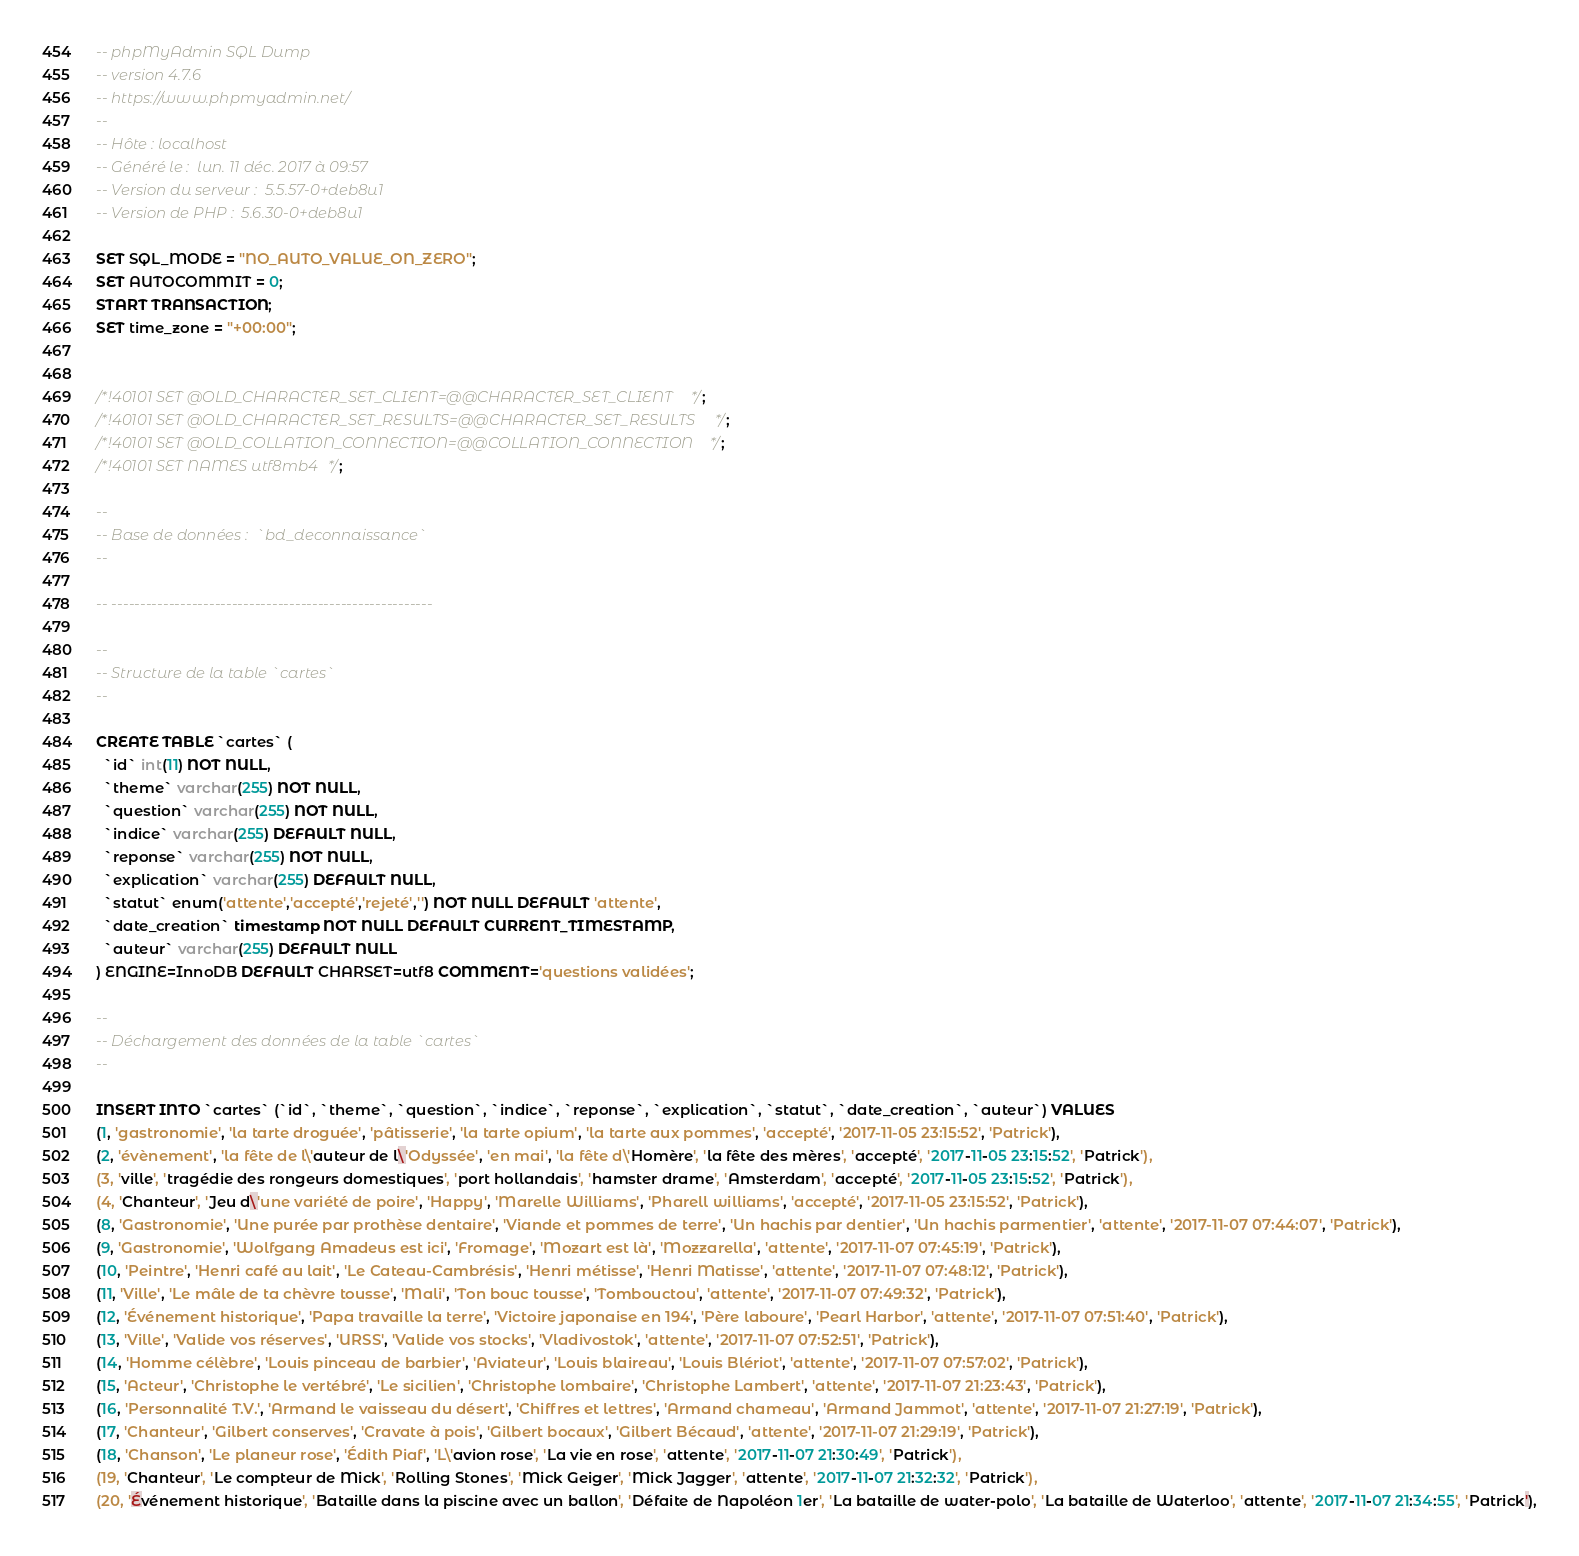Convert code to text. <code><loc_0><loc_0><loc_500><loc_500><_SQL_>-- phpMyAdmin SQL Dump
-- version 4.7.6
-- https://www.phpmyadmin.net/
--
-- Hôte : localhost
-- Généré le :  lun. 11 déc. 2017 à 09:57
-- Version du serveur :  5.5.57-0+deb8u1
-- Version de PHP :  5.6.30-0+deb8u1

SET SQL_MODE = "NO_AUTO_VALUE_ON_ZERO";
SET AUTOCOMMIT = 0;
START TRANSACTION;
SET time_zone = "+00:00";


/*!40101 SET @OLD_CHARACTER_SET_CLIENT=@@CHARACTER_SET_CLIENT */;
/*!40101 SET @OLD_CHARACTER_SET_RESULTS=@@CHARACTER_SET_RESULTS */;
/*!40101 SET @OLD_COLLATION_CONNECTION=@@COLLATION_CONNECTION */;
/*!40101 SET NAMES utf8mb4 */;

--
-- Base de données :  `bd_deconnaissance`
--

-- --------------------------------------------------------

--
-- Structure de la table `cartes`
--

CREATE TABLE `cartes` (
  `id` int(11) NOT NULL,
  `theme` varchar(255) NOT NULL,
  `question` varchar(255) NOT NULL,
  `indice` varchar(255) DEFAULT NULL,
  `reponse` varchar(255) NOT NULL,
  `explication` varchar(255) DEFAULT NULL,
  `statut` enum('attente','accepté','rejeté','') NOT NULL DEFAULT 'attente',
  `date_creation` timestamp NOT NULL DEFAULT CURRENT_TIMESTAMP,
  `auteur` varchar(255) DEFAULT NULL
) ENGINE=InnoDB DEFAULT CHARSET=utf8 COMMENT='questions validées';

--
-- Déchargement des données de la table `cartes`
--

INSERT INTO `cartes` (`id`, `theme`, `question`, `indice`, `reponse`, `explication`, `statut`, `date_creation`, `auteur`) VALUES
(1, 'gastronomie', 'la tarte droguée', 'pâtisserie', 'la tarte opium', 'la tarte aux pommes', 'accepté', '2017-11-05 23:15:52', 'Patrick'),
(2, 'évènement', 'la fête de l\'auteur de l\'Odyssée', 'en mai', 'la fête d\'Homère', 'la fête des mères', 'accepté', '2017-11-05 23:15:52', 'Patrick'),
(3, 'ville', 'tragédie des rongeurs domestiques', 'port hollandais', 'hamster drame', 'Amsterdam', 'accepté', '2017-11-05 23:15:52', 'Patrick'),
(4, 'Chanteur', 'Jeu d\'une variété de poire', 'Happy', 'Marelle Williams', 'Pharell williams', 'accepté', '2017-11-05 23:15:52', 'Patrick'),
(8, 'Gastronomie', 'Une purée par prothèse dentaire', 'Viande et pommes de terre', 'Un hachis par dentier', 'Un hachis parmentier', 'attente', '2017-11-07 07:44:07', 'Patrick'),
(9, 'Gastronomie', 'Wolfgang Amadeus est ici', 'Fromage', 'Mozart est là', 'Mozzarella', 'attente', '2017-11-07 07:45:19', 'Patrick'),
(10, 'Peintre', 'Henri café au lait', 'Le Cateau-Cambrésis', 'Henri métisse', 'Henri Matisse', 'attente', '2017-11-07 07:48:12', 'Patrick'),
(11, 'Ville', 'Le mâle de ta chèvre tousse', 'Mali', 'Ton bouc tousse', 'Tombouctou', 'attente', '2017-11-07 07:49:32', 'Patrick'),
(12, 'Événement historique', 'Papa travaille la terre', 'Victoire japonaise en 194', 'Père laboure', 'Pearl Harbor', 'attente', '2017-11-07 07:51:40', 'Patrick'),
(13, 'Ville', 'Valide vos réserves', 'URSS', 'Valide vos stocks', 'Vladivostok', 'attente', '2017-11-07 07:52:51', 'Patrick'),
(14, 'Homme célèbre', 'Louis pinceau de barbier', 'Aviateur', 'Louis blaireau', 'Louis Blériot', 'attente', '2017-11-07 07:57:02', 'Patrick'),
(15, 'Acteur', 'Christophe le vertébré', 'Le sicilien', 'Christophe lombaire', 'Christophe Lambert', 'attente', '2017-11-07 21:23:43', 'Patrick'),
(16, 'Personnalité T.V.', 'Armand le vaisseau du désert', 'Chiffres et lettres', 'Armand chameau', 'Armand Jammot', 'attente', '2017-11-07 21:27:19', 'Patrick'),
(17, 'Chanteur', 'Gilbert conserves', 'Cravate à pois', 'Gilbert bocaux', 'Gilbert Bécaud', 'attente', '2017-11-07 21:29:19', 'Patrick'),
(18, 'Chanson', 'Le planeur rose', 'Édith Piaf', 'L\'avion rose', 'La vie en rose', 'attente', '2017-11-07 21:30:49', 'Patrick'),
(19, 'Chanteur', 'Le compteur de Mick', 'Rolling Stones', 'Mick Geiger', 'Mick Jagger', 'attente', '2017-11-07 21:32:32', 'Patrick'),
(20, 'Événement historique', 'Bataille dans la piscine avec un ballon', 'Défaite de Napoléon 1er', 'La bataille de water-polo', 'La bataille de Waterloo', 'attente', '2017-11-07 21:34:55', 'Patrick'),</code> 